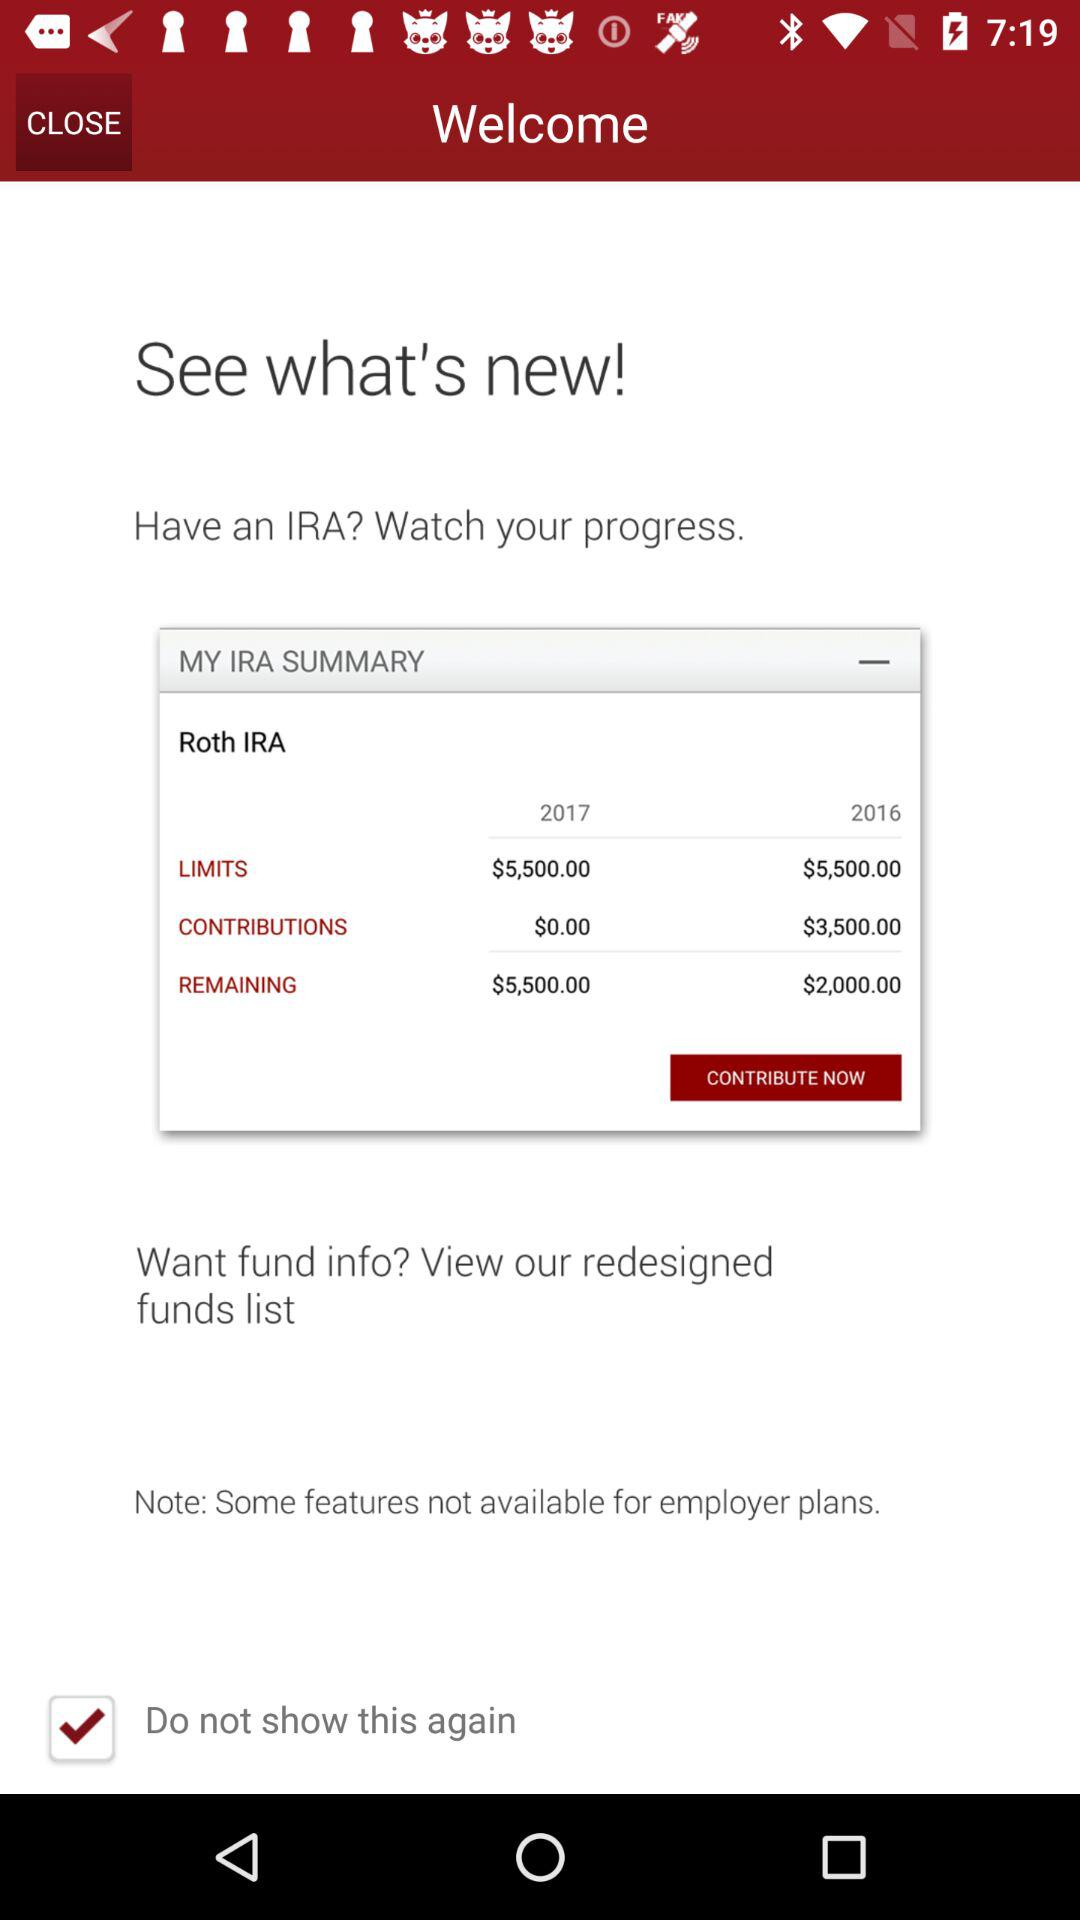What is the contribution amount for 2017? The contribution amount for 2017 is $0.00. 